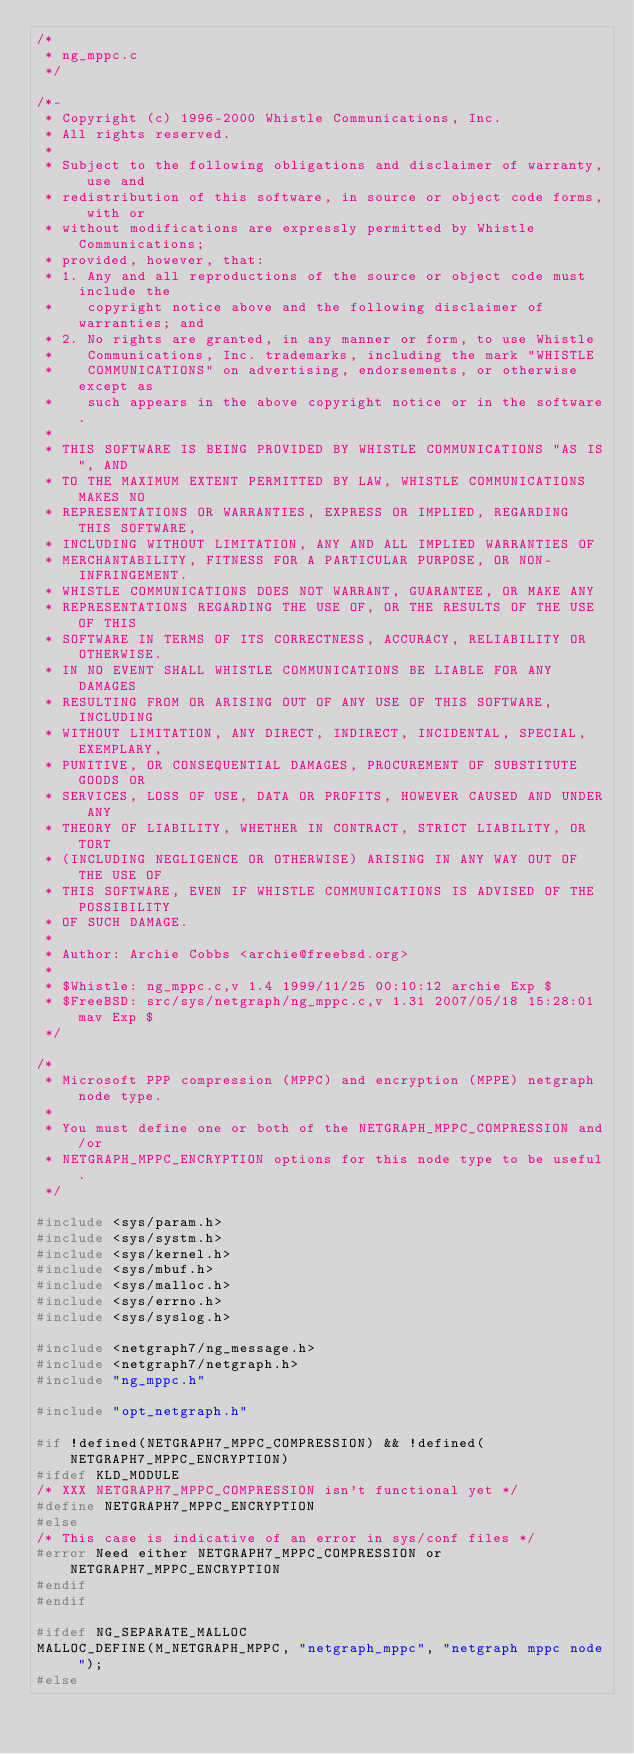Convert code to text. <code><loc_0><loc_0><loc_500><loc_500><_C_>/*
 * ng_mppc.c
 */

/*-
 * Copyright (c) 1996-2000 Whistle Communications, Inc.
 * All rights reserved.
 * 
 * Subject to the following obligations and disclaimer of warranty, use and
 * redistribution of this software, in source or object code forms, with or
 * without modifications are expressly permitted by Whistle Communications;
 * provided, however, that:
 * 1. Any and all reproductions of the source or object code must include the
 *    copyright notice above and the following disclaimer of warranties; and
 * 2. No rights are granted, in any manner or form, to use Whistle
 *    Communications, Inc. trademarks, including the mark "WHISTLE
 *    COMMUNICATIONS" on advertising, endorsements, or otherwise except as
 *    such appears in the above copyright notice or in the software.
 * 
 * THIS SOFTWARE IS BEING PROVIDED BY WHISTLE COMMUNICATIONS "AS IS", AND
 * TO THE MAXIMUM EXTENT PERMITTED BY LAW, WHISTLE COMMUNICATIONS MAKES NO
 * REPRESENTATIONS OR WARRANTIES, EXPRESS OR IMPLIED, REGARDING THIS SOFTWARE,
 * INCLUDING WITHOUT LIMITATION, ANY AND ALL IMPLIED WARRANTIES OF
 * MERCHANTABILITY, FITNESS FOR A PARTICULAR PURPOSE, OR NON-INFRINGEMENT.
 * WHISTLE COMMUNICATIONS DOES NOT WARRANT, GUARANTEE, OR MAKE ANY
 * REPRESENTATIONS REGARDING THE USE OF, OR THE RESULTS OF THE USE OF THIS
 * SOFTWARE IN TERMS OF ITS CORRECTNESS, ACCURACY, RELIABILITY OR OTHERWISE.
 * IN NO EVENT SHALL WHISTLE COMMUNICATIONS BE LIABLE FOR ANY DAMAGES
 * RESULTING FROM OR ARISING OUT OF ANY USE OF THIS SOFTWARE, INCLUDING
 * WITHOUT LIMITATION, ANY DIRECT, INDIRECT, INCIDENTAL, SPECIAL, EXEMPLARY,
 * PUNITIVE, OR CONSEQUENTIAL DAMAGES, PROCUREMENT OF SUBSTITUTE GOODS OR
 * SERVICES, LOSS OF USE, DATA OR PROFITS, HOWEVER CAUSED AND UNDER ANY
 * THEORY OF LIABILITY, WHETHER IN CONTRACT, STRICT LIABILITY, OR TORT
 * (INCLUDING NEGLIGENCE OR OTHERWISE) ARISING IN ANY WAY OUT OF THE USE OF
 * THIS SOFTWARE, EVEN IF WHISTLE COMMUNICATIONS IS ADVISED OF THE POSSIBILITY
 * OF SUCH DAMAGE.
 *
 * Author: Archie Cobbs <archie@freebsd.org>
 *
 * $Whistle: ng_mppc.c,v 1.4 1999/11/25 00:10:12 archie Exp $
 * $FreeBSD: src/sys/netgraph/ng_mppc.c,v 1.31 2007/05/18 15:28:01 mav Exp $
 */

/*
 * Microsoft PPP compression (MPPC) and encryption (MPPE) netgraph node type.
 *
 * You must define one or both of the NETGRAPH_MPPC_COMPRESSION and/or
 * NETGRAPH_MPPC_ENCRYPTION options for this node type to be useful.
 */

#include <sys/param.h>
#include <sys/systm.h>
#include <sys/kernel.h>
#include <sys/mbuf.h>
#include <sys/malloc.h>
#include <sys/errno.h>
#include <sys/syslog.h>

#include <netgraph7/ng_message.h>
#include <netgraph7/netgraph.h>
#include "ng_mppc.h"

#include "opt_netgraph.h"

#if !defined(NETGRAPH7_MPPC_COMPRESSION) && !defined(NETGRAPH7_MPPC_ENCRYPTION)
#ifdef KLD_MODULE
/* XXX NETGRAPH7_MPPC_COMPRESSION isn't functional yet */
#define NETGRAPH7_MPPC_ENCRYPTION
#else
/* This case is indicative of an error in sys/conf files */
#error Need either NETGRAPH7_MPPC_COMPRESSION or NETGRAPH7_MPPC_ENCRYPTION
#endif
#endif

#ifdef NG_SEPARATE_MALLOC
MALLOC_DEFINE(M_NETGRAPH_MPPC, "netgraph_mppc", "netgraph mppc node ");
#else</code> 